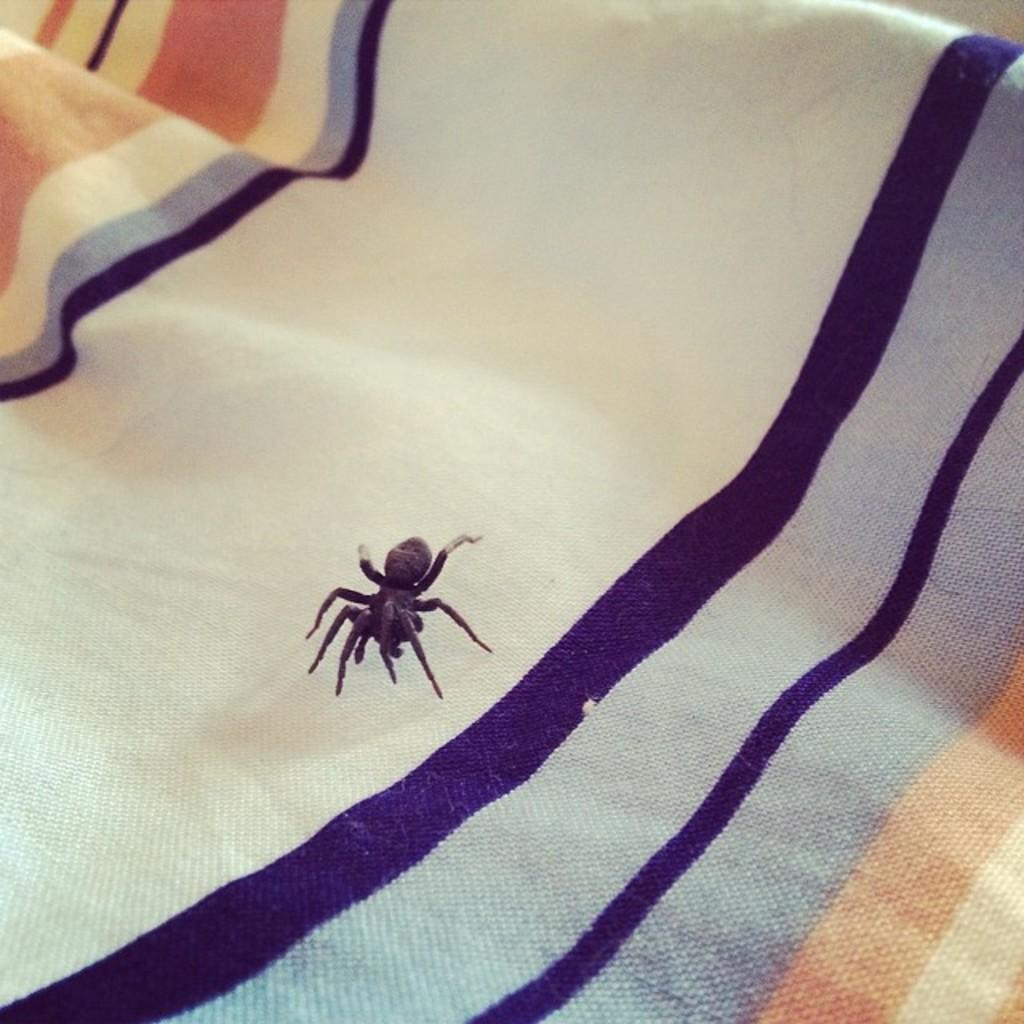What is the main subject of the image? The main subject of the image is a spider. Where is the spider located in the image? The spider is on the cloth. What year is the spider performing on stage in the image? There is no stage or performance in the image, and the year cannot be determined from the image. 